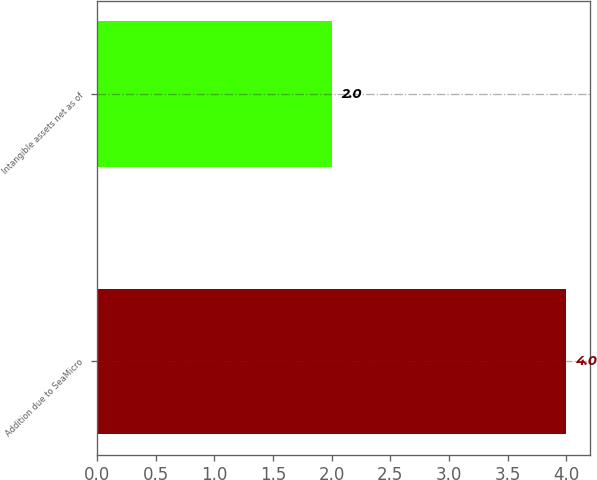Convert chart to OTSL. <chart><loc_0><loc_0><loc_500><loc_500><bar_chart><fcel>Addition due to SeaMicro<fcel>Intangible assets net as of<nl><fcel>4<fcel>2<nl></chart> 